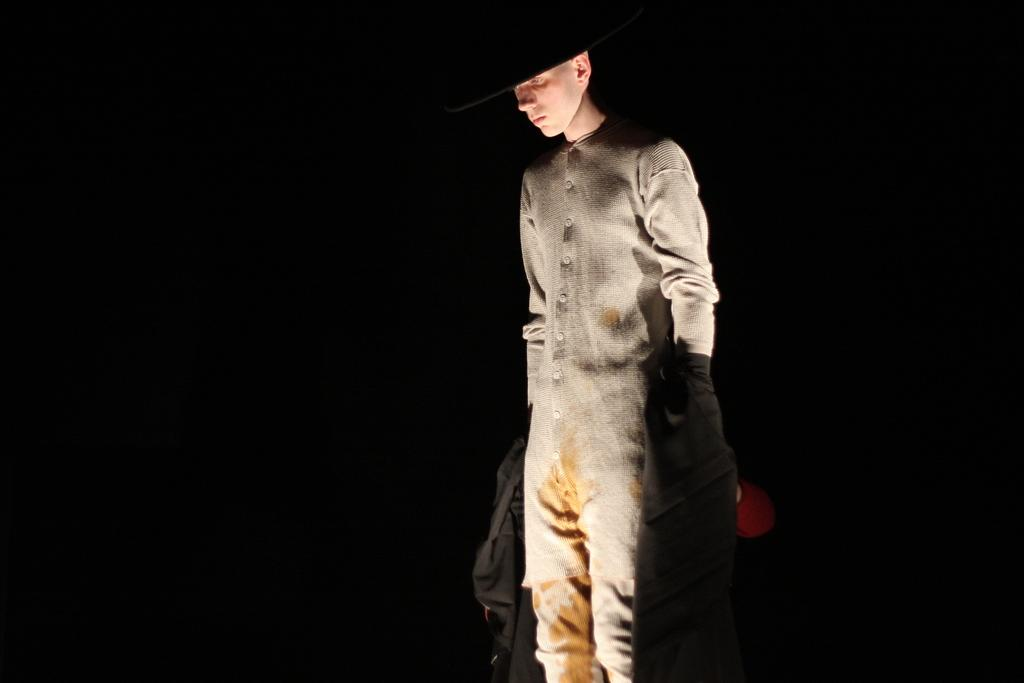What is the main subject of the image? There is a person standing in the image. Can you describe the background of the image? The background of the image is dark. What grade of polish is being applied to the seashore in the image? There is no seashore or polish present in the image; it features a person standing against a dark background. 